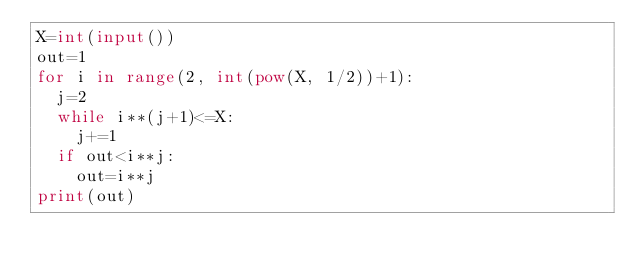<code> <loc_0><loc_0><loc_500><loc_500><_Python_>X=int(input())
out=1
for i in range(2, int(pow(X, 1/2))+1):
  j=2
  while i**(j+1)<=X:
    j+=1
  if out<i**j:
    out=i**j
print(out)</code> 